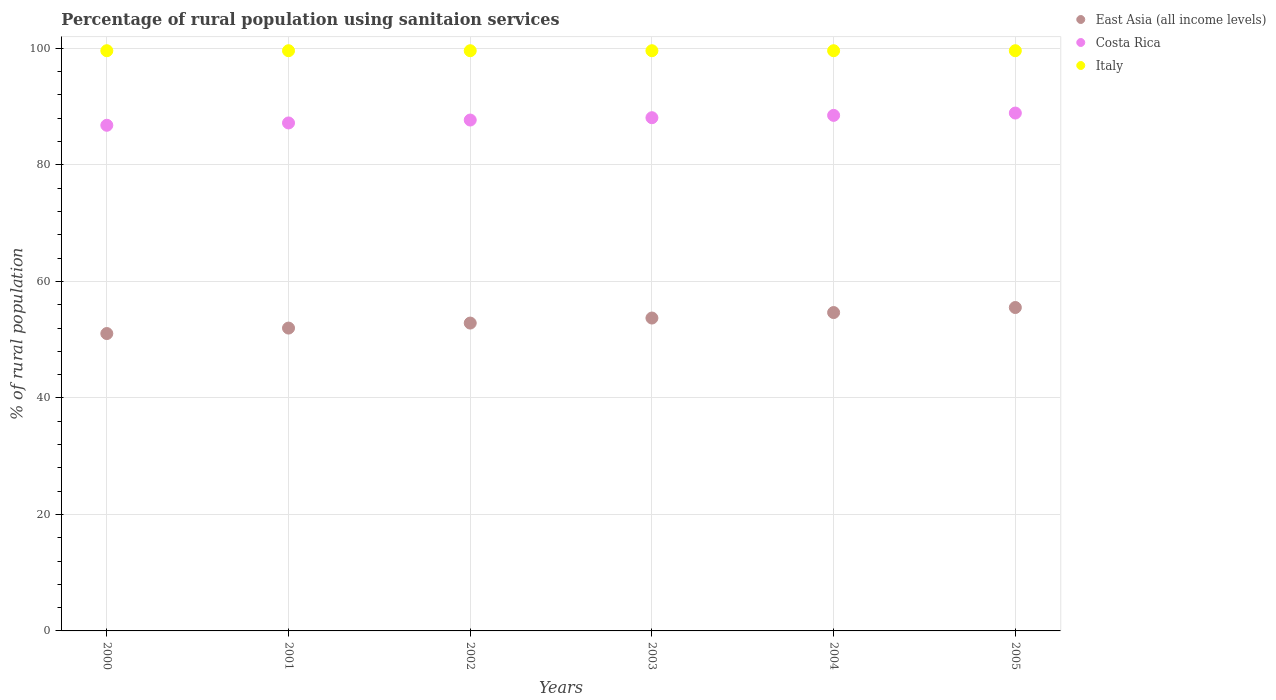How many different coloured dotlines are there?
Provide a short and direct response. 3. Is the number of dotlines equal to the number of legend labels?
Your answer should be very brief. Yes. What is the percentage of rural population using sanitaion services in Italy in 2005?
Provide a succinct answer. 99.6. Across all years, what is the maximum percentage of rural population using sanitaion services in Italy?
Your answer should be compact. 99.6. Across all years, what is the minimum percentage of rural population using sanitaion services in East Asia (all income levels)?
Your answer should be very brief. 51.05. In which year was the percentage of rural population using sanitaion services in Italy minimum?
Your response must be concise. 2000. What is the total percentage of rural population using sanitaion services in East Asia (all income levels) in the graph?
Make the answer very short. 319.76. What is the difference between the percentage of rural population using sanitaion services in East Asia (all income levels) in 2002 and that in 2005?
Keep it short and to the point. -2.67. What is the difference between the percentage of rural population using sanitaion services in Italy in 2005 and the percentage of rural population using sanitaion services in East Asia (all income levels) in 2000?
Give a very brief answer. 48.55. What is the average percentage of rural population using sanitaion services in East Asia (all income levels) per year?
Ensure brevity in your answer.  53.29. In the year 2005, what is the difference between the percentage of rural population using sanitaion services in Italy and percentage of rural population using sanitaion services in Costa Rica?
Make the answer very short. 10.7. In how many years, is the percentage of rural population using sanitaion services in Italy greater than 24 %?
Your answer should be compact. 6. What is the ratio of the percentage of rural population using sanitaion services in East Asia (all income levels) in 2004 to that in 2005?
Make the answer very short. 0.98. Is the percentage of rural population using sanitaion services in Italy in 2000 less than that in 2005?
Keep it short and to the point. No. Is the difference between the percentage of rural population using sanitaion services in Italy in 2002 and 2005 greater than the difference between the percentage of rural population using sanitaion services in Costa Rica in 2002 and 2005?
Your answer should be very brief. Yes. What is the difference between the highest and the second highest percentage of rural population using sanitaion services in East Asia (all income levels)?
Provide a short and direct response. 0.86. In how many years, is the percentage of rural population using sanitaion services in Italy greater than the average percentage of rural population using sanitaion services in Italy taken over all years?
Offer a terse response. 0. How many dotlines are there?
Your answer should be very brief. 3. What is the difference between two consecutive major ticks on the Y-axis?
Provide a succinct answer. 20. Where does the legend appear in the graph?
Provide a short and direct response. Top right. How are the legend labels stacked?
Your response must be concise. Vertical. What is the title of the graph?
Provide a short and direct response. Percentage of rural population using sanitaion services. What is the label or title of the X-axis?
Give a very brief answer. Years. What is the label or title of the Y-axis?
Make the answer very short. % of rural population. What is the % of rural population in East Asia (all income levels) in 2000?
Give a very brief answer. 51.05. What is the % of rural population in Costa Rica in 2000?
Make the answer very short. 86.8. What is the % of rural population of Italy in 2000?
Your answer should be compact. 99.6. What is the % of rural population of East Asia (all income levels) in 2001?
Make the answer very short. 51.99. What is the % of rural population in Costa Rica in 2001?
Give a very brief answer. 87.2. What is the % of rural population in Italy in 2001?
Your answer should be compact. 99.6. What is the % of rural population in East Asia (all income levels) in 2002?
Provide a succinct answer. 52.85. What is the % of rural population in Costa Rica in 2002?
Ensure brevity in your answer.  87.7. What is the % of rural population of Italy in 2002?
Ensure brevity in your answer.  99.6. What is the % of rural population in East Asia (all income levels) in 2003?
Give a very brief answer. 53.71. What is the % of rural population in Costa Rica in 2003?
Keep it short and to the point. 88.1. What is the % of rural population of Italy in 2003?
Make the answer very short. 99.6. What is the % of rural population in East Asia (all income levels) in 2004?
Offer a terse response. 54.65. What is the % of rural population in Costa Rica in 2004?
Offer a very short reply. 88.5. What is the % of rural population in Italy in 2004?
Give a very brief answer. 99.6. What is the % of rural population in East Asia (all income levels) in 2005?
Offer a terse response. 55.52. What is the % of rural population of Costa Rica in 2005?
Your answer should be compact. 88.9. What is the % of rural population of Italy in 2005?
Give a very brief answer. 99.6. Across all years, what is the maximum % of rural population in East Asia (all income levels)?
Provide a short and direct response. 55.52. Across all years, what is the maximum % of rural population in Costa Rica?
Your response must be concise. 88.9. Across all years, what is the maximum % of rural population of Italy?
Your answer should be compact. 99.6. Across all years, what is the minimum % of rural population in East Asia (all income levels)?
Provide a succinct answer. 51.05. Across all years, what is the minimum % of rural population of Costa Rica?
Your answer should be very brief. 86.8. Across all years, what is the minimum % of rural population in Italy?
Your answer should be compact. 99.6. What is the total % of rural population of East Asia (all income levels) in the graph?
Offer a very short reply. 319.76. What is the total % of rural population of Costa Rica in the graph?
Your answer should be very brief. 527.2. What is the total % of rural population in Italy in the graph?
Your answer should be compact. 597.6. What is the difference between the % of rural population in East Asia (all income levels) in 2000 and that in 2001?
Your answer should be very brief. -0.94. What is the difference between the % of rural population of Italy in 2000 and that in 2001?
Ensure brevity in your answer.  0. What is the difference between the % of rural population in East Asia (all income levels) in 2000 and that in 2002?
Your response must be concise. -1.8. What is the difference between the % of rural population of East Asia (all income levels) in 2000 and that in 2003?
Your answer should be very brief. -2.66. What is the difference between the % of rural population in Costa Rica in 2000 and that in 2003?
Your answer should be compact. -1.3. What is the difference between the % of rural population of East Asia (all income levels) in 2000 and that in 2004?
Provide a succinct answer. -3.6. What is the difference between the % of rural population of Italy in 2000 and that in 2004?
Make the answer very short. 0. What is the difference between the % of rural population in East Asia (all income levels) in 2000 and that in 2005?
Your answer should be compact. -4.47. What is the difference between the % of rural population of Italy in 2000 and that in 2005?
Keep it short and to the point. 0. What is the difference between the % of rural population of East Asia (all income levels) in 2001 and that in 2002?
Your answer should be very brief. -0.86. What is the difference between the % of rural population of Costa Rica in 2001 and that in 2002?
Your response must be concise. -0.5. What is the difference between the % of rural population in Italy in 2001 and that in 2002?
Provide a succinct answer. 0. What is the difference between the % of rural population of East Asia (all income levels) in 2001 and that in 2003?
Provide a succinct answer. -1.72. What is the difference between the % of rural population in Costa Rica in 2001 and that in 2003?
Offer a terse response. -0.9. What is the difference between the % of rural population of Italy in 2001 and that in 2003?
Make the answer very short. 0. What is the difference between the % of rural population in East Asia (all income levels) in 2001 and that in 2004?
Offer a terse response. -2.67. What is the difference between the % of rural population of East Asia (all income levels) in 2001 and that in 2005?
Offer a very short reply. -3.53. What is the difference between the % of rural population in Italy in 2001 and that in 2005?
Offer a very short reply. 0. What is the difference between the % of rural population of East Asia (all income levels) in 2002 and that in 2003?
Provide a succinct answer. -0.86. What is the difference between the % of rural population in Costa Rica in 2002 and that in 2003?
Your answer should be compact. -0.4. What is the difference between the % of rural population in East Asia (all income levels) in 2002 and that in 2004?
Your answer should be very brief. -1.8. What is the difference between the % of rural population of East Asia (all income levels) in 2002 and that in 2005?
Provide a short and direct response. -2.67. What is the difference between the % of rural population in East Asia (all income levels) in 2003 and that in 2004?
Your answer should be very brief. -0.94. What is the difference between the % of rural population of Costa Rica in 2003 and that in 2004?
Your answer should be compact. -0.4. What is the difference between the % of rural population in Italy in 2003 and that in 2004?
Offer a very short reply. 0. What is the difference between the % of rural population in East Asia (all income levels) in 2003 and that in 2005?
Your answer should be very brief. -1.81. What is the difference between the % of rural population in Costa Rica in 2003 and that in 2005?
Keep it short and to the point. -0.8. What is the difference between the % of rural population in East Asia (all income levels) in 2004 and that in 2005?
Keep it short and to the point. -0.86. What is the difference between the % of rural population of Costa Rica in 2004 and that in 2005?
Provide a short and direct response. -0.4. What is the difference between the % of rural population in Italy in 2004 and that in 2005?
Offer a terse response. 0. What is the difference between the % of rural population in East Asia (all income levels) in 2000 and the % of rural population in Costa Rica in 2001?
Ensure brevity in your answer.  -36.15. What is the difference between the % of rural population of East Asia (all income levels) in 2000 and the % of rural population of Italy in 2001?
Give a very brief answer. -48.55. What is the difference between the % of rural population of Costa Rica in 2000 and the % of rural population of Italy in 2001?
Provide a succinct answer. -12.8. What is the difference between the % of rural population of East Asia (all income levels) in 2000 and the % of rural population of Costa Rica in 2002?
Your answer should be very brief. -36.65. What is the difference between the % of rural population of East Asia (all income levels) in 2000 and the % of rural population of Italy in 2002?
Provide a succinct answer. -48.55. What is the difference between the % of rural population of East Asia (all income levels) in 2000 and the % of rural population of Costa Rica in 2003?
Offer a terse response. -37.05. What is the difference between the % of rural population of East Asia (all income levels) in 2000 and the % of rural population of Italy in 2003?
Your answer should be very brief. -48.55. What is the difference between the % of rural population in East Asia (all income levels) in 2000 and the % of rural population in Costa Rica in 2004?
Provide a short and direct response. -37.45. What is the difference between the % of rural population of East Asia (all income levels) in 2000 and the % of rural population of Italy in 2004?
Make the answer very short. -48.55. What is the difference between the % of rural population in Costa Rica in 2000 and the % of rural population in Italy in 2004?
Your response must be concise. -12.8. What is the difference between the % of rural population of East Asia (all income levels) in 2000 and the % of rural population of Costa Rica in 2005?
Ensure brevity in your answer.  -37.85. What is the difference between the % of rural population in East Asia (all income levels) in 2000 and the % of rural population in Italy in 2005?
Provide a succinct answer. -48.55. What is the difference between the % of rural population of East Asia (all income levels) in 2001 and the % of rural population of Costa Rica in 2002?
Your answer should be compact. -35.71. What is the difference between the % of rural population of East Asia (all income levels) in 2001 and the % of rural population of Italy in 2002?
Your response must be concise. -47.61. What is the difference between the % of rural population of Costa Rica in 2001 and the % of rural population of Italy in 2002?
Your answer should be compact. -12.4. What is the difference between the % of rural population of East Asia (all income levels) in 2001 and the % of rural population of Costa Rica in 2003?
Provide a short and direct response. -36.11. What is the difference between the % of rural population in East Asia (all income levels) in 2001 and the % of rural population in Italy in 2003?
Your answer should be very brief. -47.61. What is the difference between the % of rural population of East Asia (all income levels) in 2001 and the % of rural population of Costa Rica in 2004?
Your answer should be compact. -36.51. What is the difference between the % of rural population in East Asia (all income levels) in 2001 and the % of rural population in Italy in 2004?
Keep it short and to the point. -47.61. What is the difference between the % of rural population of East Asia (all income levels) in 2001 and the % of rural population of Costa Rica in 2005?
Provide a succinct answer. -36.91. What is the difference between the % of rural population in East Asia (all income levels) in 2001 and the % of rural population in Italy in 2005?
Your answer should be compact. -47.61. What is the difference between the % of rural population in Costa Rica in 2001 and the % of rural population in Italy in 2005?
Your response must be concise. -12.4. What is the difference between the % of rural population of East Asia (all income levels) in 2002 and the % of rural population of Costa Rica in 2003?
Provide a succinct answer. -35.25. What is the difference between the % of rural population in East Asia (all income levels) in 2002 and the % of rural population in Italy in 2003?
Offer a very short reply. -46.75. What is the difference between the % of rural population in Costa Rica in 2002 and the % of rural population in Italy in 2003?
Offer a terse response. -11.9. What is the difference between the % of rural population of East Asia (all income levels) in 2002 and the % of rural population of Costa Rica in 2004?
Your answer should be compact. -35.65. What is the difference between the % of rural population of East Asia (all income levels) in 2002 and the % of rural population of Italy in 2004?
Make the answer very short. -46.75. What is the difference between the % of rural population of East Asia (all income levels) in 2002 and the % of rural population of Costa Rica in 2005?
Keep it short and to the point. -36.05. What is the difference between the % of rural population in East Asia (all income levels) in 2002 and the % of rural population in Italy in 2005?
Offer a terse response. -46.75. What is the difference between the % of rural population in Costa Rica in 2002 and the % of rural population in Italy in 2005?
Your answer should be very brief. -11.9. What is the difference between the % of rural population in East Asia (all income levels) in 2003 and the % of rural population in Costa Rica in 2004?
Give a very brief answer. -34.79. What is the difference between the % of rural population in East Asia (all income levels) in 2003 and the % of rural population in Italy in 2004?
Ensure brevity in your answer.  -45.89. What is the difference between the % of rural population of Costa Rica in 2003 and the % of rural population of Italy in 2004?
Ensure brevity in your answer.  -11.5. What is the difference between the % of rural population of East Asia (all income levels) in 2003 and the % of rural population of Costa Rica in 2005?
Your answer should be compact. -35.19. What is the difference between the % of rural population of East Asia (all income levels) in 2003 and the % of rural population of Italy in 2005?
Offer a terse response. -45.89. What is the difference between the % of rural population of East Asia (all income levels) in 2004 and the % of rural population of Costa Rica in 2005?
Give a very brief answer. -34.25. What is the difference between the % of rural population in East Asia (all income levels) in 2004 and the % of rural population in Italy in 2005?
Offer a very short reply. -44.95. What is the average % of rural population in East Asia (all income levels) per year?
Your answer should be compact. 53.29. What is the average % of rural population of Costa Rica per year?
Your answer should be very brief. 87.87. What is the average % of rural population of Italy per year?
Keep it short and to the point. 99.6. In the year 2000, what is the difference between the % of rural population in East Asia (all income levels) and % of rural population in Costa Rica?
Make the answer very short. -35.75. In the year 2000, what is the difference between the % of rural population in East Asia (all income levels) and % of rural population in Italy?
Provide a succinct answer. -48.55. In the year 2001, what is the difference between the % of rural population in East Asia (all income levels) and % of rural population in Costa Rica?
Provide a short and direct response. -35.21. In the year 2001, what is the difference between the % of rural population in East Asia (all income levels) and % of rural population in Italy?
Your response must be concise. -47.61. In the year 2001, what is the difference between the % of rural population in Costa Rica and % of rural population in Italy?
Your response must be concise. -12.4. In the year 2002, what is the difference between the % of rural population in East Asia (all income levels) and % of rural population in Costa Rica?
Provide a succinct answer. -34.85. In the year 2002, what is the difference between the % of rural population of East Asia (all income levels) and % of rural population of Italy?
Provide a short and direct response. -46.75. In the year 2002, what is the difference between the % of rural population of Costa Rica and % of rural population of Italy?
Offer a very short reply. -11.9. In the year 2003, what is the difference between the % of rural population of East Asia (all income levels) and % of rural population of Costa Rica?
Your response must be concise. -34.39. In the year 2003, what is the difference between the % of rural population of East Asia (all income levels) and % of rural population of Italy?
Ensure brevity in your answer.  -45.89. In the year 2004, what is the difference between the % of rural population in East Asia (all income levels) and % of rural population in Costa Rica?
Ensure brevity in your answer.  -33.85. In the year 2004, what is the difference between the % of rural population of East Asia (all income levels) and % of rural population of Italy?
Your answer should be compact. -44.95. In the year 2005, what is the difference between the % of rural population in East Asia (all income levels) and % of rural population in Costa Rica?
Provide a short and direct response. -33.38. In the year 2005, what is the difference between the % of rural population of East Asia (all income levels) and % of rural population of Italy?
Your response must be concise. -44.08. In the year 2005, what is the difference between the % of rural population of Costa Rica and % of rural population of Italy?
Keep it short and to the point. -10.7. What is the ratio of the % of rural population of East Asia (all income levels) in 2000 to that in 2001?
Your answer should be very brief. 0.98. What is the ratio of the % of rural population in Italy in 2000 to that in 2002?
Keep it short and to the point. 1. What is the ratio of the % of rural population of East Asia (all income levels) in 2000 to that in 2003?
Provide a succinct answer. 0.95. What is the ratio of the % of rural population of Costa Rica in 2000 to that in 2003?
Offer a terse response. 0.99. What is the ratio of the % of rural population in East Asia (all income levels) in 2000 to that in 2004?
Ensure brevity in your answer.  0.93. What is the ratio of the % of rural population in Costa Rica in 2000 to that in 2004?
Your answer should be compact. 0.98. What is the ratio of the % of rural population in East Asia (all income levels) in 2000 to that in 2005?
Keep it short and to the point. 0.92. What is the ratio of the % of rural population in Costa Rica in 2000 to that in 2005?
Your answer should be compact. 0.98. What is the ratio of the % of rural population of Italy in 2000 to that in 2005?
Your response must be concise. 1. What is the ratio of the % of rural population in East Asia (all income levels) in 2001 to that in 2002?
Provide a short and direct response. 0.98. What is the ratio of the % of rural population in Costa Rica in 2001 to that in 2002?
Provide a succinct answer. 0.99. What is the ratio of the % of rural population of Italy in 2001 to that in 2002?
Keep it short and to the point. 1. What is the ratio of the % of rural population in East Asia (all income levels) in 2001 to that in 2003?
Offer a terse response. 0.97. What is the ratio of the % of rural population of Costa Rica in 2001 to that in 2003?
Make the answer very short. 0.99. What is the ratio of the % of rural population of East Asia (all income levels) in 2001 to that in 2004?
Give a very brief answer. 0.95. What is the ratio of the % of rural population in Costa Rica in 2001 to that in 2004?
Offer a very short reply. 0.99. What is the ratio of the % of rural population of Italy in 2001 to that in 2004?
Give a very brief answer. 1. What is the ratio of the % of rural population of East Asia (all income levels) in 2001 to that in 2005?
Give a very brief answer. 0.94. What is the ratio of the % of rural population in Costa Rica in 2001 to that in 2005?
Your response must be concise. 0.98. What is the ratio of the % of rural population in Italy in 2001 to that in 2005?
Your response must be concise. 1. What is the ratio of the % of rural population of East Asia (all income levels) in 2002 to that in 2003?
Make the answer very short. 0.98. What is the ratio of the % of rural population of Italy in 2002 to that in 2003?
Offer a very short reply. 1. What is the ratio of the % of rural population of East Asia (all income levels) in 2002 to that in 2004?
Make the answer very short. 0.97. What is the ratio of the % of rural population in Costa Rica in 2002 to that in 2004?
Keep it short and to the point. 0.99. What is the ratio of the % of rural population in East Asia (all income levels) in 2002 to that in 2005?
Offer a very short reply. 0.95. What is the ratio of the % of rural population of Costa Rica in 2002 to that in 2005?
Give a very brief answer. 0.99. What is the ratio of the % of rural population in Italy in 2002 to that in 2005?
Make the answer very short. 1. What is the ratio of the % of rural population in East Asia (all income levels) in 2003 to that in 2004?
Give a very brief answer. 0.98. What is the ratio of the % of rural population in Costa Rica in 2003 to that in 2004?
Provide a succinct answer. 1. What is the ratio of the % of rural population in Italy in 2003 to that in 2004?
Offer a very short reply. 1. What is the ratio of the % of rural population of East Asia (all income levels) in 2003 to that in 2005?
Offer a very short reply. 0.97. What is the ratio of the % of rural population in Italy in 2003 to that in 2005?
Keep it short and to the point. 1. What is the ratio of the % of rural population in East Asia (all income levels) in 2004 to that in 2005?
Your response must be concise. 0.98. What is the ratio of the % of rural population in Costa Rica in 2004 to that in 2005?
Keep it short and to the point. 1. What is the difference between the highest and the second highest % of rural population of East Asia (all income levels)?
Offer a very short reply. 0.86. What is the difference between the highest and the second highest % of rural population in Costa Rica?
Offer a terse response. 0.4. What is the difference between the highest and the second highest % of rural population in Italy?
Ensure brevity in your answer.  0. What is the difference between the highest and the lowest % of rural population of East Asia (all income levels)?
Your answer should be compact. 4.47. What is the difference between the highest and the lowest % of rural population of Costa Rica?
Provide a short and direct response. 2.1. What is the difference between the highest and the lowest % of rural population in Italy?
Your response must be concise. 0. 